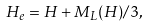Convert formula to latex. <formula><loc_0><loc_0><loc_500><loc_500>H _ { e } = H + M _ { L } ( H ) / 3 ,</formula> 